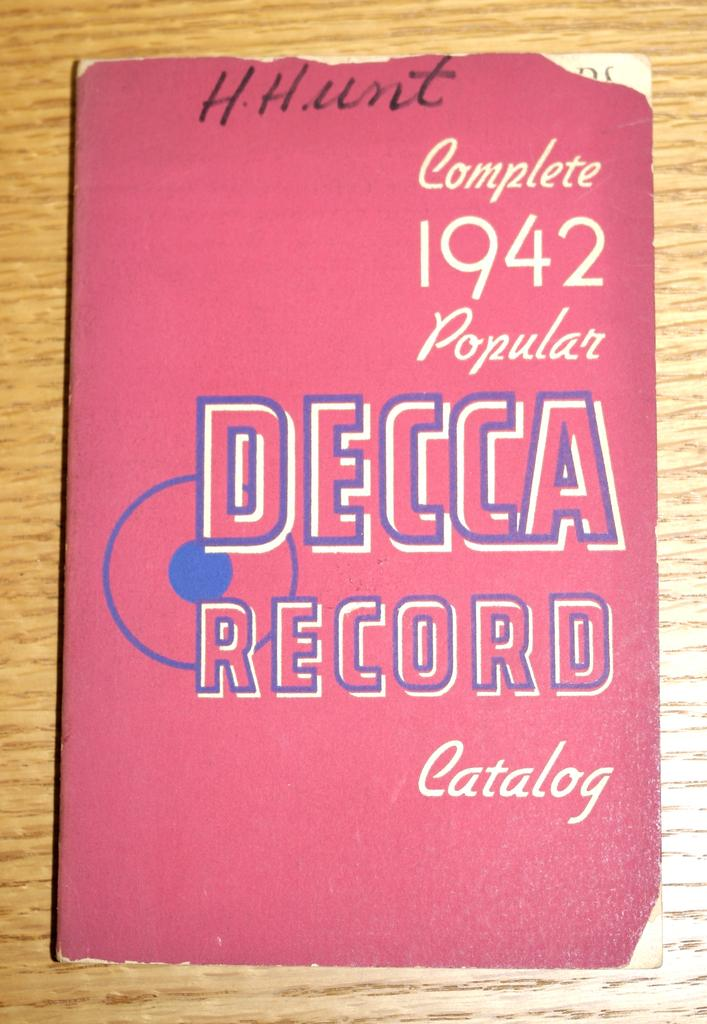<image>
Provide a brief description of the given image. A book of a complete 1942 Popular Decca Record Catalog 